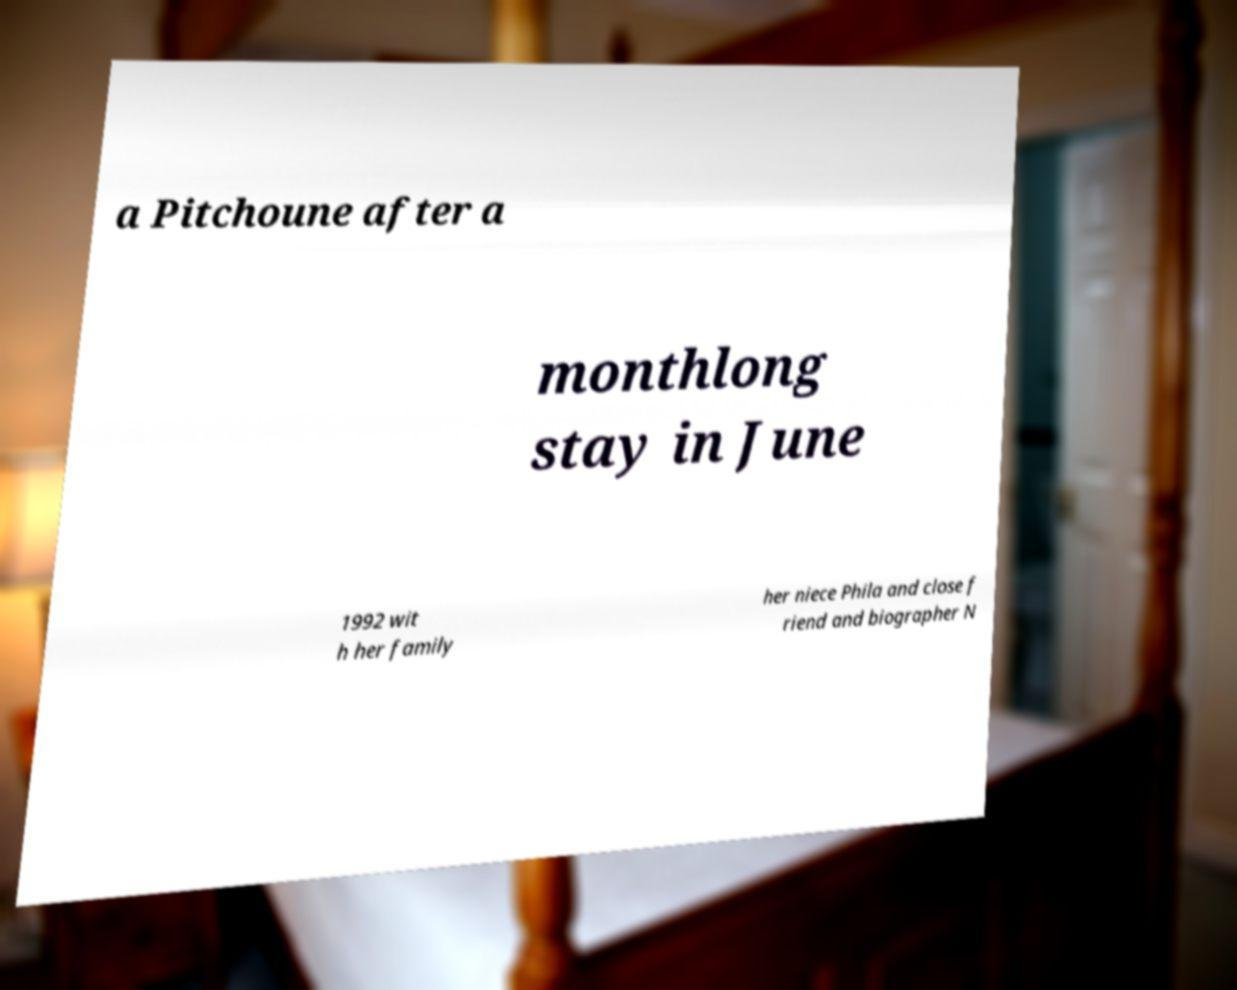Could you assist in decoding the text presented in this image and type it out clearly? a Pitchoune after a monthlong stay in June 1992 wit h her family her niece Phila and close f riend and biographer N 